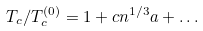Convert formula to latex. <formula><loc_0><loc_0><loc_500><loc_500>T _ { c } / T _ { c } ^ { ( 0 ) } = 1 + c n ^ { 1 / 3 } a + \dots</formula> 